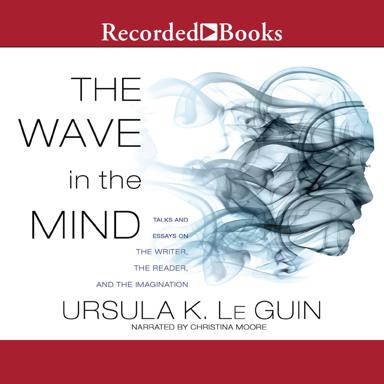Can you describe what kind of themes are explored in this book? The themes in 'The Wave in the Mind' primarily delve into the realm of how language influences thought and the reciprocal relationship between the writer and the reader. Ursula K. Le Guin discusses the role of gender, culture, and history in shaping narrative forms, alongside exploring her own experiences with storytelling. 